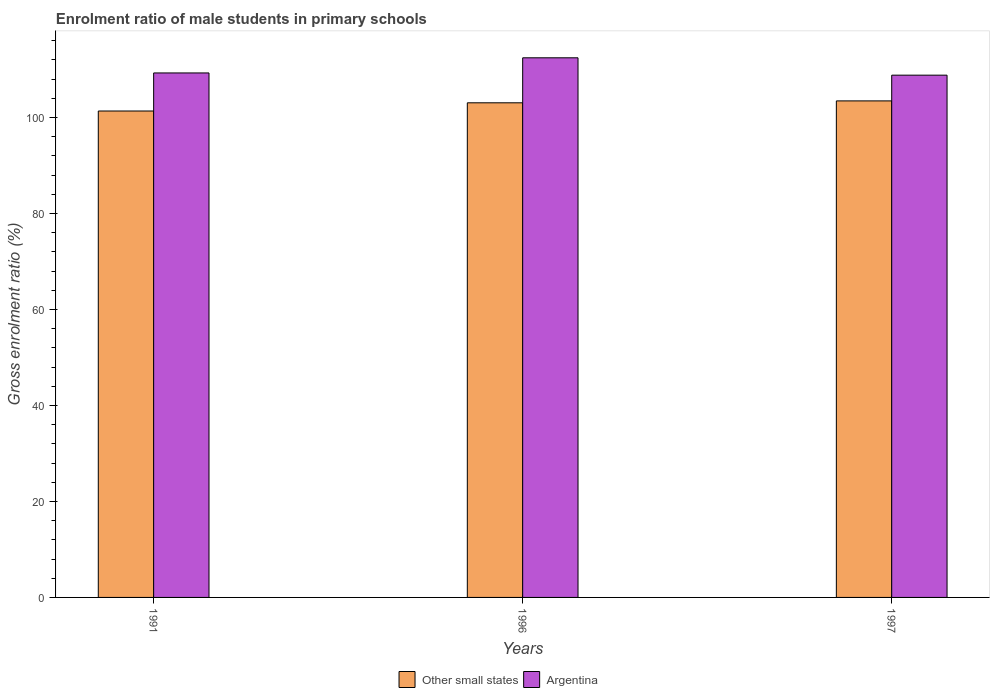How many different coloured bars are there?
Offer a terse response. 2. How many groups of bars are there?
Give a very brief answer. 3. Are the number of bars per tick equal to the number of legend labels?
Make the answer very short. Yes. Are the number of bars on each tick of the X-axis equal?
Your answer should be compact. Yes. How many bars are there on the 2nd tick from the left?
Ensure brevity in your answer.  2. What is the label of the 3rd group of bars from the left?
Ensure brevity in your answer.  1997. In how many cases, is the number of bars for a given year not equal to the number of legend labels?
Give a very brief answer. 0. What is the enrolment ratio of male students in primary schools in Argentina in 1996?
Ensure brevity in your answer.  112.42. Across all years, what is the maximum enrolment ratio of male students in primary schools in Argentina?
Your answer should be compact. 112.42. Across all years, what is the minimum enrolment ratio of male students in primary schools in Other small states?
Offer a terse response. 101.33. What is the total enrolment ratio of male students in primary schools in Other small states in the graph?
Give a very brief answer. 307.81. What is the difference between the enrolment ratio of male students in primary schools in Other small states in 1991 and that in 1996?
Keep it short and to the point. -1.71. What is the difference between the enrolment ratio of male students in primary schools in Argentina in 1997 and the enrolment ratio of male students in primary schools in Other small states in 1991?
Give a very brief answer. 7.47. What is the average enrolment ratio of male students in primary schools in Other small states per year?
Give a very brief answer. 102.6. In the year 1996, what is the difference between the enrolment ratio of male students in primary schools in Other small states and enrolment ratio of male students in primary schools in Argentina?
Your answer should be compact. -9.37. What is the ratio of the enrolment ratio of male students in primary schools in Other small states in 1996 to that in 1997?
Provide a succinct answer. 1. Is the difference between the enrolment ratio of male students in primary schools in Other small states in 1991 and 1997 greater than the difference between the enrolment ratio of male students in primary schools in Argentina in 1991 and 1997?
Keep it short and to the point. No. What is the difference between the highest and the second highest enrolment ratio of male students in primary schools in Other small states?
Offer a very short reply. 0.4. What is the difference between the highest and the lowest enrolment ratio of male students in primary schools in Argentina?
Provide a short and direct response. 3.62. In how many years, is the enrolment ratio of male students in primary schools in Argentina greater than the average enrolment ratio of male students in primary schools in Argentina taken over all years?
Your response must be concise. 1. Is the sum of the enrolment ratio of male students in primary schools in Argentina in 1991 and 1997 greater than the maximum enrolment ratio of male students in primary schools in Other small states across all years?
Your answer should be very brief. Yes. What does the 1st bar from the left in 1997 represents?
Your answer should be very brief. Other small states. What does the 2nd bar from the right in 1997 represents?
Your answer should be compact. Other small states. Are all the bars in the graph horizontal?
Provide a succinct answer. No. Does the graph contain grids?
Provide a short and direct response. No. Where does the legend appear in the graph?
Your answer should be very brief. Bottom center. How are the legend labels stacked?
Make the answer very short. Horizontal. What is the title of the graph?
Your response must be concise. Enrolment ratio of male students in primary schools. Does "Guinea" appear as one of the legend labels in the graph?
Your answer should be very brief. No. What is the label or title of the X-axis?
Provide a short and direct response. Years. What is the label or title of the Y-axis?
Provide a succinct answer. Gross enrolment ratio (%). What is the Gross enrolment ratio (%) of Other small states in 1991?
Provide a short and direct response. 101.33. What is the Gross enrolment ratio (%) in Argentina in 1991?
Keep it short and to the point. 109.26. What is the Gross enrolment ratio (%) in Other small states in 1996?
Make the answer very short. 103.04. What is the Gross enrolment ratio (%) in Argentina in 1996?
Provide a succinct answer. 112.42. What is the Gross enrolment ratio (%) of Other small states in 1997?
Your response must be concise. 103.44. What is the Gross enrolment ratio (%) in Argentina in 1997?
Provide a short and direct response. 108.8. Across all years, what is the maximum Gross enrolment ratio (%) in Other small states?
Give a very brief answer. 103.44. Across all years, what is the maximum Gross enrolment ratio (%) in Argentina?
Provide a short and direct response. 112.42. Across all years, what is the minimum Gross enrolment ratio (%) of Other small states?
Ensure brevity in your answer.  101.33. Across all years, what is the minimum Gross enrolment ratio (%) of Argentina?
Your response must be concise. 108.8. What is the total Gross enrolment ratio (%) of Other small states in the graph?
Your answer should be very brief. 307.81. What is the total Gross enrolment ratio (%) in Argentina in the graph?
Provide a succinct answer. 330.48. What is the difference between the Gross enrolment ratio (%) in Other small states in 1991 and that in 1996?
Provide a short and direct response. -1.71. What is the difference between the Gross enrolment ratio (%) in Argentina in 1991 and that in 1996?
Your response must be concise. -3.15. What is the difference between the Gross enrolment ratio (%) of Other small states in 1991 and that in 1997?
Offer a terse response. -2.11. What is the difference between the Gross enrolment ratio (%) in Argentina in 1991 and that in 1997?
Make the answer very short. 0.46. What is the difference between the Gross enrolment ratio (%) of Other small states in 1996 and that in 1997?
Your answer should be very brief. -0.4. What is the difference between the Gross enrolment ratio (%) of Argentina in 1996 and that in 1997?
Your response must be concise. 3.62. What is the difference between the Gross enrolment ratio (%) of Other small states in 1991 and the Gross enrolment ratio (%) of Argentina in 1996?
Provide a succinct answer. -11.08. What is the difference between the Gross enrolment ratio (%) in Other small states in 1991 and the Gross enrolment ratio (%) in Argentina in 1997?
Offer a terse response. -7.47. What is the difference between the Gross enrolment ratio (%) of Other small states in 1996 and the Gross enrolment ratio (%) of Argentina in 1997?
Provide a succinct answer. -5.76. What is the average Gross enrolment ratio (%) of Other small states per year?
Offer a very short reply. 102.6. What is the average Gross enrolment ratio (%) in Argentina per year?
Keep it short and to the point. 110.16. In the year 1991, what is the difference between the Gross enrolment ratio (%) of Other small states and Gross enrolment ratio (%) of Argentina?
Offer a terse response. -7.93. In the year 1996, what is the difference between the Gross enrolment ratio (%) in Other small states and Gross enrolment ratio (%) in Argentina?
Make the answer very short. -9.37. In the year 1997, what is the difference between the Gross enrolment ratio (%) in Other small states and Gross enrolment ratio (%) in Argentina?
Provide a short and direct response. -5.36. What is the ratio of the Gross enrolment ratio (%) of Other small states in 1991 to that in 1996?
Your answer should be very brief. 0.98. What is the ratio of the Gross enrolment ratio (%) in Argentina in 1991 to that in 1996?
Your response must be concise. 0.97. What is the ratio of the Gross enrolment ratio (%) in Other small states in 1991 to that in 1997?
Your answer should be compact. 0.98. What is the ratio of the Gross enrolment ratio (%) of Argentina in 1991 to that in 1997?
Your response must be concise. 1. What is the ratio of the Gross enrolment ratio (%) in Other small states in 1996 to that in 1997?
Your response must be concise. 1. What is the ratio of the Gross enrolment ratio (%) of Argentina in 1996 to that in 1997?
Keep it short and to the point. 1.03. What is the difference between the highest and the second highest Gross enrolment ratio (%) of Other small states?
Give a very brief answer. 0.4. What is the difference between the highest and the second highest Gross enrolment ratio (%) of Argentina?
Provide a short and direct response. 3.15. What is the difference between the highest and the lowest Gross enrolment ratio (%) in Other small states?
Offer a very short reply. 2.11. What is the difference between the highest and the lowest Gross enrolment ratio (%) of Argentina?
Your answer should be very brief. 3.62. 